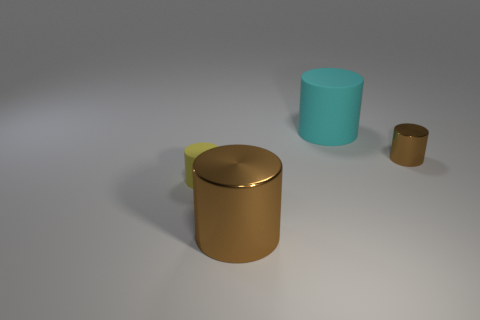What is the size of the thing that is both in front of the tiny brown cylinder and right of the yellow matte cylinder?
Provide a succinct answer. Large. The yellow object that is the same shape as the tiny brown thing is what size?
Offer a terse response. Small. Is the number of rubber cylinders that are behind the tiny yellow rubber cylinder greater than the number of tiny yellow rubber cylinders on the right side of the large cyan matte thing?
Keep it short and to the point. Yes. The big rubber thing that is the same shape as the tiny yellow rubber thing is what color?
Offer a very short reply. Cyan. Does the big metal thing have the same shape as the rubber thing right of the yellow rubber thing?
Give a very brief answer. Yes. What number of other objects are there of the same material as the tiny brown thing?
Your answer should be compact. 1. Is the color of the small matte object the same as the large thing that is in front of the small shiny thing?
Your answer should be compact. No. There is a big cylinder to the left of the cyan cylinder; what is it made of?
Provide a succinct answer. Metal. Is there a large metal cube that has the same color as the large metal object?
Keep it short and to the point. No. There is a cylinder that is the same size as the yellow object; what is its color?
Provide a short and direct response. Brown. 